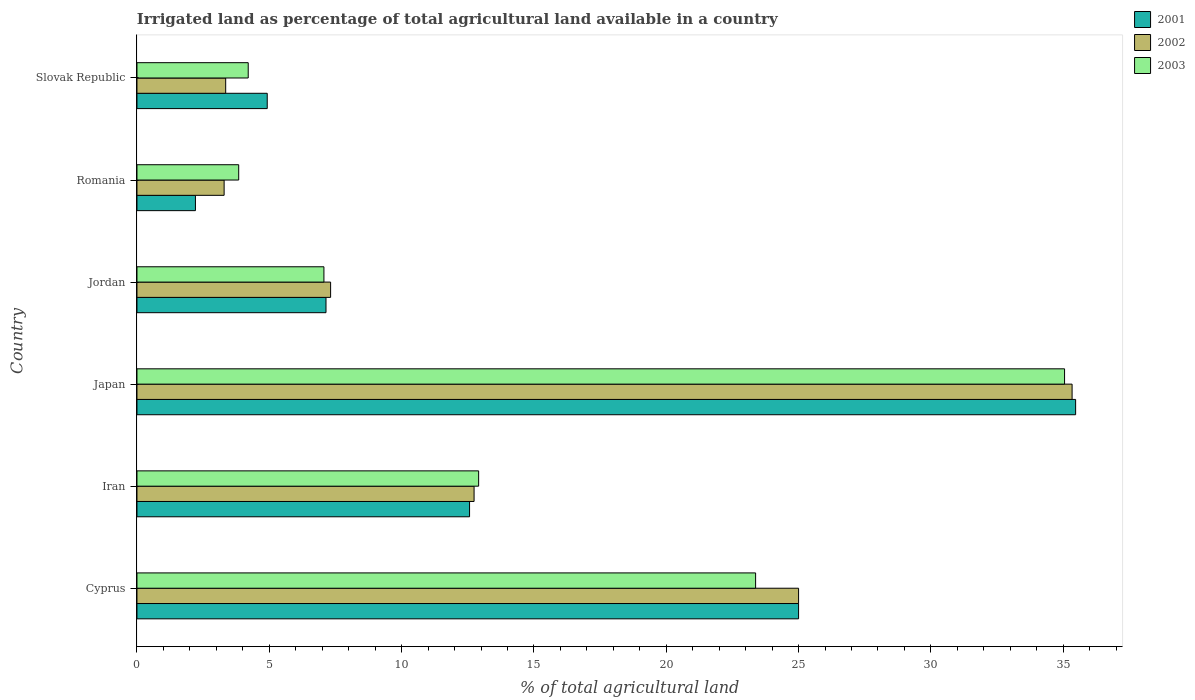How many different coloured bars are there?
Make the answer very short. 3. Are the number of bars per tick equal to the number of legend labels?
Keep it short and to the point. Yes. What is the label of the 6th group of bars from the top?
Offer a very short reply. Cyprus. In how many cases, is the number of bars for a given country not equal to the number of legend labels?
Offer a very short reply. 0. What is the percentage of irrigated land in 2003 in Japan?
Your answer should be compact. 35.05. Across all countries, what is the maximum percentage of irrigated land in 2003?
Offer a very short reply. 35.05. Across all countries, what is the minimum percentage of irrigated land in 2003?
Your response must be concise. 3.84. In which country was the percentage of irrigated land in 2002 minimum?
Provide a short and direct response. Romania. What is the total percentage of irrigated land in 2003 in the graph?
Offer a very short reply. 86.45. What is the difference between the percentage of irrigated land in 2002 in Iran and that in Jordan?
Make the answer very short. 5.42. What is the difference between the percentage of irrigated land in 2003 in Romania and the percentage of irrigated land in 2001 in Japan?
Offer a terse response. -31.62. What is the average percentage of irrigated land in 2002 per country?
Keep it short and to the point. 14.51. In how many countries, is the percentage of irrigated land in 2002 greater than 7 %?
Offer a very short reply. 4. What is the ratio of the percentage of irrigated land in 2001 in Romania to that in Slovak Republic?
Keep it short and to the point. 0.45. Is the difference between the percentage of irrigated land in 2001 in Jordan and Romania greater than the difference between the percentage of irrigated land in 2002 in Jordan and Romania?
Your answer should be very brief. Yes. What is the difference between the highest and the second highest percentage of irrigated land in 2001?
Keep it short and to the point. 10.47. What is the difference between the highest and the lowest percentage of irrigated land in 2003?
Keep it short and to the point. 31.21. In how many countries, is the percentage of irrigated land in 2001 greater than the average percentage of irrigated land in 2001 taken over all countries?
Offer a very short reply. 2. What does the 3rd bar from the top in Romania represents?
Your response must be concise. 2001. Is it the case that in every country, the sum of the percentage of irrigated land in 2002 and percentage of irrigated land in 2001 is greater than the percentage of irrigated land in 2003?
Your answer should be very brief. Yes. Are all the bars in the graph horizontal?
Make the answer very short. Yes. Does the graph contain any zero values?
Offer a very short reply. No. Where does the legend appear in the graph?
Provide a short and direct response. Top right. What is the title of the graph?
Your answer should be compact. Irrigated land as percentage of total agricultural land available in a country. Does "2000" appear as one of the legend labels in the graph?
Offer a terse response. No. What is the label or title of the X-axis?
Ensure brevity in your answer.  % of total agricultural land. What is the % of total agricultural land of 2002 in Cyprus?
Offer a very short reply. 25. What is the % of total agricultural land of 2003 in Cyprus?
Your answer should be very brief. 23.38. What is the % of total agricultural land of 2001 in Iran?
Keep it short and to the point. 12.57. What is the % of total agricultural land in 2002 in Iran?
Your answer should be very brief. 12.74. What is the % of total agricultural land in 2003 in Iran?
Provide a short and direct response. 12.91. What is the % of total agricultural land of 2001 in Japan?
Your answer should be very brief. 35.47. What is the % of total agricultural land in 2002 in Japan?
Provide a succinct answer. 35.33. What is the % of total agricultural land of 2003 in Japan?
Your answer should be compact. 35.05. What is the % of total agricultural land in 2001 in Jordan?
Provide a short and direct response. 7.14. What is the % of total agricultural land in 2002 in Jordan?
Provide a short and direct response. 7.32. What is the % of total agricultural land in 2003 in Jordan?
Offer a very short reply. 7.06. What is the % of total agricultural land of 2001 in Romania?
Provide a short and direct response. 2.21. What is the % of total agricultural land of 2002 in Romania?
Make the answer very short. 3.29. What is the % of total agricultural land of 2003 in Romania?
Ensure brevity in your answer.  3.84. What is the % of total agricultural land in 2001 in Slovak Republic?
Your answer should be compact. 4.92. What is the % of total agricultural land of 2002 in Slovak Republic?
Your response must be concise. 3.35. What is the % of total agricultural land of 2003 in Slovak Republic?
Ensure brevity in your answer.  4.2. Across all countries, what is the maximum % of total agricultural land of 2001?
Your answer should be very brief. 35.47. Across all countries, what is the maximum % of total agricultural land of 2002?
Ensure brevity in your answer.  35.33. Across all countries, what is the maximum % of total agricultural land in 2003?
Give a very brief answer. 35.05. Across all countries, what is the minimum % of total agricultural land of 2001?
Provide a short and direct response. 2.21. Across all countries, what is the minimum % of total agricultural land in 2002?
Ensure brevity in your answer.  3.29. Across all countries, what is the minimum % of total agricultural land of 2003?
Your answer should be very brief. 3.84. What is the total % of total agricultural land in 2001 in the graph?
Keep it short and to the point. 87.31. What is the total % of total agricultural land of 2002 in the graph?
Ensure brevity in your answer.  87.04. What is the total % of total agricultural land of 2003 in the graph?
Your answer should be compact. 86.45. What is the difference between the % of total agricultural land in 2001 in Cyprus and that in Iran?
Give a very brief answer. 12.43. What is the difference between the % of total agricultural land of 2002 in Cyprus and that in Iran?
Offer a very short reply. 12.26. What is the difference between the % of total agricultural land in 2003 in Cyprus and that in Iran?
Your answer should be very brief. 10.47. What is the difference between the % of total agricultural land in 2001 in Cyprus and that in Japan?
Provide a short and direct response. -10.47. What is the difference between the % of total agricultural land of 2002 in Cyprus and that in Japan?
Keep it short and to the point. -10.33. What is the difference between the % of total agricultural land of 2003 in Cyprus and that in Japan?
Ensure brevity in your answer.  -11.67. What is the difference between the % of total agricultural land of 2001 in Cyprus and that in Jordan?
Offer a very short reply. 17.86. What is the difference between the % of total agricultural land of 2002 in Cyprus and that in Jordan?
Make the answer very short. 17.68. What is the difference between the % of total agricultural land of 2003 in Cyprus and that in Jordan?
Give a very brief answer. 16.31. What is the difference between the % of total agricultural land in 2001 in Cyprus and that in Romania?
Give a very brief answer. 22.79. What is the difference between the % of total agricultural land in 2002 in Cyprus and that in Romania?
Provide a short and direct response. 21.71. What is the difference between the % of total agricultural land of 2003 in Cyprus and that in Romania?
Your answer should be compact. 19.53. What is the difference between the % of total agricultural land in 2001 in Cyprus and that in Slovak Republic?
Your answer should be very brief. 20.08. What is the difference between the % of total agricultural land of 2002 in Cyprus and that in Slovak Republic?
Keep it short and to the point. 21.65. What is the difference between the % of total agricultural land in 2003 in Cyprus and that in Slovak Republic?
Offer a terse response. 19.17. What is the difference between the % of total agricultural land in 2001 in Iran and that in Japan?
Make the answer very short. -22.9. What is the difference between the % of total agricultural land of 2002 in Iran and that in Japan?
Your response must be concise. -22.6. What is the difference between the % of total agricultural land of 2003 in Iran and that in Japan?
Ensure brevity in your answer.  -22.14. What is the difference between the % of total agricultural land in 2001 in Iran and that in Jordan?
Keep it short and to the point. 5.42. What is the difference between the % of total agricultural land of 2002 in Iran and that in Jordan?
Provide a succinct answer. 5.42. What is the difference between the % of total agricultural land of 2003 in Iran and that in Jordan?
Make the answer very short. 5.85. What is the difference between the % of total agricultural land of 2001 in Iran and that in Romania?
Keep it short and to the point. 10.36. What is the difference between the % of total agricultural land in 2002 in Iran and that in Romania?
Ensure brevity in your answer.  9.44. What is the difference between the % of total agricultural land in 2003 in Iran and that in Romania?
Give a very brief answer. 9.07. What is the difference between the % of total agricultural land in 2001 in Iran and that in Slovak Republic?
Keep it short and to the point. 7.65. What is the difference between the % of total agricultural land in 2002 in Iran and that in Slovak Republic?
Your answer should be compact. 9.39. What is the difference between the % of total agricultural land in 2003 in Iran and that in Slovak Republic?
Keep it short and to the point. 8.71. What is the difference between the % of total agricultural land of 2001 in Japan and that in Jordan?
Provide a short and direct response. 28.33. What is the difference between the % of total agricultural land of 2002 in Japan and that in Jordan?
Provide a short and direct response. 28.02. What is the difference between the % of total agricultural land of 2003 in Japan and that in Jordan?
Give a very brief answer. 27.99. What is the difference between the % of total agricultural land of 2001 in Japan and that in Romania?
Make the answer very short. 33.26. What is the difference between the % of total agricultural land of 2002 in Japan and that in Romania?
Your answer should be very brief. 32.04. What is the difference between the % of total agricultural land in 2003 in Japan and that in Romania?
Give a very brief answer. 31.21. What is the difference between the % of total agricultural land in 2001 in Japan and that in Slovak Republic?
Provide a short and direct response. 30.55. What is the difference between the % of total agricultural land in 2002 in Japan and that in Slovak Republic?
Provide a short and direct response. 31.98. What is the difference between the % of total agricultural land of 2003 in Japan and that in Slovak Republic?
Keep it short and to the point. 30.85. What is the difference between the % of total agricultural land in 2001 in Jordan and that in Romania?
Ensure brevity in your answer.  4.93. What is the difference between the % of total agricultural land in 2002 in Jordan and that in Romania?
Offer a very short reply. 4.02. What is the difference between the % of total agricultural land in 2003 in Jordan and that in Romania?
Make the answer very short. 3.22. What is the difference between the % of total agricultural land of 2001 in Jordan and that in Slovak Republic?
Offer a very short reply. 2.22. What is the difference between the % of total agricultural land in 2002 in Jordan and that in Slovak Republic?
Make the answer very short. 3.96. What is the difference between the % of total agricultural land of 2003 in Jordan and that in Slovak Republic?
Your response must be concise. 2.86. What is the difference between the % of total agricultural land of 2001 in Romania and that in Slovak Republic?
Provide a short and direct response. -2.71. What is the difference between the % of total agricultural land of 2002 in Romania and that in Slovak Republic?
Offer a terse response. -0.06. What is the difference between the % of total agricultural land of 2003 in Romania and that in Slovak Republic?
Make the answer very short. -0.36. What is the difference between the % of total agricultural land of 2001 in Cyprus and the % of total agricultural land of 2002 in Iran?
Your response must be concise. 12.26. What is the difference between the % of total agricultural land in 2001 in Cyprus and the % of total agricultural land in 2003 in Iran?
Provide a short and direct response. 12.09. What is the difference between the % of total agricultural land of 2002 in Cyprus and the % of total agricultural land of 2003 in Iran?
Provide a succinct answer. 12.09. What is the difference between the % of total agricultural land of 2001 in Cyprus and the % of total agricultural land of 2002 in Japan?
Offer a very short reply. -10.33. What is the difference between the % of total agricultural land in 2001 in Cyprus and the % of total agricultural land in 2003 in Japan?
Provide a succinct answer. -10.05. What is the difference between the % of total agricultural land of 2002 in Cyprus and the % of total agricultural land of 2003 in Japan?
Your answer should be compact. -10.05. What is the difference between the % of total agricultural land in 2001 in Cyprus and the % of total agricultural land in 2002 in Jordan?
Ensure brevity in your answer.  17.68. What is the difference between the % of total agricultural land in 2001 in Cyprus and the % of total agricultural land in 2003 in Jordan?
Ensure brevity in your answer.  17.94. What is the difference between the % of total agricultural land in 2002 in Cyprus and the % of total agricultural land in 2003 in Jordan?
Provide a succinct answer. 17.94. What is the difference between the % of total agricultural land in 2001 in Cyprus and the % of total agricultural land in 2002 in Romania?
Give a very brief answer. 21.71. What is the difference between the % of total agricultural land of 2001 in Cyprus and the % of total agricultural land of 2003 in Romania?
Give a very brief answer. 21.16. What is the difference between the % of total agricultural land of 2002 in Cyprus and the % of total agricultural land of 2003 in Romania?
Your answer should be compact. 21.16. What is the difference between the % of total agricultural land in 2001 in Cyprus and the % of total agricultural land in 2002 in Slovak Republic?
Offer a terse response. 21.65. What is the difference between the % of total agricultural land in 2001 in Cyprus and the % of total agricultural land in 2003 in Slovak Republic?
Your answer should be very brief. 20.8. What is the difference between the % of total agricultural land in 2002 in Cyprus and the % of total agricultural land in 2003 in Slovak Republic?
Your answer should be very brief. 20.8. What is the difference between the % of total agricultural land in 2001 in Iran and the % of total agricultural land in 2002 in Japan?
Your response must be concise. -22.77. What is the difference between the % of total agricultural land in 2001 in Iran and the % of total agricultural land in 2003 in Japan?
Provide a succinct answer. -22.48. What is the difference between the % of total agricultural land of 2002 in Iran and the % of total agricultural land of 2003 in Japan?
Your response must be concise. -22.31. What is the difference between the % of total agricultural land of 2001 in Iran and the % of total agricultural land of 2002 in Jordan?
Keep it short and to the point. 5.25. What is the difference between the % of total agricultural land in 2001 in Iran and the % of total agricultural land in 2003 in Jordan?
Give a very brief answer. 5.5. What is the difference between the % of total agricultural land in 2002 in Iran and the % of total agricultural land in 2003 in Jordan?
Provide a short and direct response. 5.67. What is the difference between the % of total agricultural land of 2001 in Iran and the % of total agricultural land of 2002 in Romania?
Make the answer very short. 9.27. What is the difference between the % of total agricultural land of 2001 in Iran and the % of total agricultural land of 2003 in Romania?
Keep it short and to the point. 8.72. What is the difference between the % of total agricultural land in 2002 in Iran and the % of total agricultural land in 2003 in Romania?
Offer a terse response. 8.89. What is the difference between the % of total agricultural land of 2001 in Iran and the % of total agricultural land of 2002 in Slovak Republic?
Your answer should be very brief. 9.21. What is the difference between the % of total agricultural land in 2001 in Iran and the % of total agricultural land in 2003 in Slovak Republic?
Give a very brief answer. 8.36. What is the difference between the % of total agricultural land in 2002 in Iran and the % of total agricultural land in 2003 in Slovak Republic?
Your response must be concise. 8.53. What is the difference between the % of total agricultural land in 2001 in Japan and the % of total agricultural land in 2002 in Jordan?
Your answer should be compact. 28.15. What is the difference between the % of total agricultural land in 2001 in Japan and the % of total agricultural land in 2003 in Jordan?
Your answer should be very brief. 28.4. What is the difference between the % of total agricultural land of 2002 in Japan and the % of total agricultural land of 2003 in Jordan?
Offer a very short reply. 28.27. What is the difference between the % of total agricultural land of 2001 in Japan and the % of total agricultural land of 2002 in Romania?
Offer a terse response. 32.18. What is the difference between the % of total agricultural land of 2001 in Japan and the % of total agricultural land of 2003 in Romania?
Your response must be concise. 31.62. What is the difference between the % of total agricultural land in 2002 in Japan and the % of total agricultural land in 2003 in Romania?
Offer a terse response. 31.49. What is the difference between the % of total agricultural land of 2001 in Japan and the % of total agricultural land of 2002 in Slovak Republic?
Provide a short and direct response. 32.12. What is the difference between the % of total agricultural land of 2001 in Japan and the % of total agricultural land of 2003 in Slovak Republic?
Offer a very short reply. 31.26. What is the difference between the % of total agricultural land in 2002 in Japan and the % of total agricultural land in 2003 in Slovak Republic?
Provide a short and direct response. 31.13. What is the difference between the % of total agricultural land in 2001 in Jordan and the % of total agricultural land in 2002 in Romania?
Offer a terse response. 3.85. What is the difference between the % of total agricultural land in 2001 in Jordan and the % of total agricultural land in 2003 in Romania?
Make the answer very short. 3.3. What is the difference between the % of total agricultural land in 2002 in Jordan and the % of total agricultural land in 2003 in Romania?
Give a very brief answer. 3.47. What is the difference between the % of total agricultural land in 2001 in Jordan and the % of total agricultural land in 2002 in Slovak Republic?
Keep it short and to the point. 3.79. What is the difference between the % of total agricultural land in 2001 in Jordan and the % of total agricultural land in 2003 in Slovak Republic?
Provide a succinct answer. 2.94. What is the difference between the % of total agricultural land of 2002 in Jordan and the % of total agricultural land of 2003 in Slovak Republic?
Offer a terse response. 3.11. What is the difference between the % of total agricultural land in 2001 in Romania and the % of total agricultural land in 2002 in Slovak Republic?
Offer a very short reply. -1.14. What is the difference between the % of total agricultural land in 2001 in Romania and the % of total agricultural land in 2003 in Slovak Republic?
Provide a succinct answer. -1.99. What is the difference between the % of total agricultural land of 2002 in Romania and the % of total agricultural land of 2003 in Slovak Republic?
Make the answer very short. -0.91. What is the average % of total agricultural land in 2001 per country?
Keep it short and to the point. 14.55. What is the average % of total agricultural land in 2002 per country?
Your response must be concise. 14.51. What is the average % of total agricultural land of 2003 per country?
Offer a very short reply. 14.41. What is the difference between the % of total agricultural land in 2001 and % of total agricultural land in 2002 in Cyprus?
Your response must be concise. 0. What is the difference between the % of total agricultural land in 2001 and % of total agricultural land in 2003 in Cyprus?
Offer a very short reply. 1.62. What is the difference between the % of total agricultural land in 2002 and % of total agricultural land in 2003 in Cyprus?
Offer a terse response. 1.62. What is the difference between the % of total agricultural land in 2001 and % of total agricultural land in 2002 in Iran?
Make the answer very short. -0.17. What is the difference between the % of total agricultural land of 2001 and % of total agricultural land of 2003 in Iran?
Offer a terse response. -0.34. What is the difference between the % of total agricultural land of 2002 and % of total agricultural land of 2003 in Iran?
Keep it short and to the point. -0.17. What is the difference between the % of total agricultural land in 2001 and % of total agricultural land in 2002 in Japan?
Your answer should be very brief. 0.13. What is the difference between the % of total agricultural land in 2001 and % of total agricultural land in 2003 in Japan?
Keep it short and to the point. 0.42. What is the difference between the % of total agricultural land of 2002 and % of total agricultural land of 2003 in Japan?
Your response must be concise. 0.28. What is the difference between the % of total agricultural land of 2001 and % of total agricultural land of 2002 in Jordan?
Offer a very short reply. -0.17. What is the difference between the % of total agricultural land of 2001 and % of total agricultural land of 2003 in Jordan?
Provide a succinct answer. 0.08. What is the difference between the % of total agricultural land in 2002 and % of total agricultural land in 2003 in Jordan?
Your response must be concise. 0.25. What is the difference between the % of total agricultural land in 2001 and % of total agricultural land in 2002 in Romania?
Make the answer very short. -1.08. What is the difference between the % of total agricultural land of 2001 and % of total agricultural land of 2003 in Romania?
Ensure brevity in your answer.  -1.63. What is the difference between the % of total agricultural land in 2002 and % of total agricultural land in 2003 in Romania?
Provide a short and direct response. -0.55. What is the difference between the % of total agricultural land of 2001 and % of total agricultural land of 2002 in Slovak Republic?
Give a very brief answer. 1.57. What is the difference between the % of total agricultural land of 2001 and % of total agricultural land of 2003 in Slovak Republic?
Provide a succinct answer. 0.72. What is the difference between the % of total agricultural land in 2002 and % of total agricultural land in 2003 in Slovak Republic?
Ensure brevity in your answer.  -0.85. What is the ratio of the % of total agricultural land of 2001 in Cyprus to that in Iran?
Offer a terse response. 1.99. What is the ratio of the % of total agricultural land of 2002 in Cyprus to that in Iran?
Your response must be concise. 1.96. What is the ratio of the % of total agricultural land in 2003 in Cyprus to that in Iran?
Keep it short and to the point. 1.81. What is the ratio of the % of total agricultural land in 2001 in Cyprus to that in Japan?
Make the answer very short. 0.7. What is the ratio of the % of total agricultural land of 2002 in Cyprus to that in Japan?
Make the answer very short. 0.71. What is the ratio of the % of total agricultural land of 2003 in Cyprus to that in Japan?
Keep it short and to the point. 0.67. What is the ratio of the % of total agricultural land in 2001 in Cyprus to that in Jordan?
Ensure brevity in your answer.  3.5. What is the ratio of the % of total agricultural land in 2002 in Cyprus to that in Jordan?
Provide a succinct answer. 3.42. What is the ratio of the % of total agricultural land in 2003 in Cyprus to that in Jordan?
Offer a terse response. 3.31. What is the ratio of the % of total agricultural land in 2001 in Cyprus to that in Romania?
Offer a terse response. 11.31. What is the ratio of the % of total agricultural land in 2002 in Cyprus to that in Romania?
Keep it short and to the point. 7.59. What is the ratio of the % of total agricultural land in 2003 in Cyprus to that in Romania?
Give a very brief answer. 6.08. What is the ratio of the % of total agricultural land in 2001 in Cyprus to that in Slovak Republic?
Your answer should be compact. 5.08. What is the ratio of the % of total agricultural land in 2002 in Cyprus to that in Slovak Republic?
Ensure brevity in your answer.  7.46. What is the ratio of the % of total agricultural land of 2003 in Cyprus to that in Slovak Republic?
Ensure brevity in your answer.  5.56. What is the ratio of the % of total agricultural land in 2001 in Iran to that in Japan?
Keep it short and to the point. 0.35. What is the ratio of the % of total agricultural land of 2002 in Iran to that in Japan?
Your response must be concise. 0.36. What is the ratio of the % of total agricultural land of 2003 in Iran to that in Japan?
Your answer should be very brief. 0.37. What is the ratio of the % of total agricultural land of 2001 in Iran to that in Jordan?
Your answer should be compact. 1.76. What is the ratio of the % of total agricultural land in 2002 in Iran to that in Jordan?
Your answer should be compact. 1.74. What is the ratio of the % of total agricultural land in 2003 in Iran to that in Jordan?
Offer a terse response. 1.83. What is the ratio of the % of total agricultural land in 2001 in Iran to that in Romania?
Your response must be concise. 5.69. What is the ratio of the % of total agricultural land of 2002 in Iran to that in Romania?
Give a very brief answer. 3.87. What is the ratio of the % of total agricultural land of 2003 in Iran to that in Romania?
Ensure brevity in your answer.  3.36. What is the ratio of the % of total agricultural land in 2001 in Iran to that in Slovak Republic?
Provide a succinct answer. 2.55. What is the ratio of the % of total agricultural land in 2002 in Iran to that in Slovak Republic?
Ensure brevity in your answer.  3.8. What is the ratio of the % of total agricultural land of 2003 in Iran to that in Slovak Republic?
Offer a terse response. 3.07. What is the ratio of the % of total agricultural land of 2001 in Japan to that in Jordan?
Your answer should be compact. 4.97. What is the ratio of the % of total agricultural land of 2002 in Japan to that in Jordan?
Provide a short and direct response. 4.83. What is the ratio of the % of total agricultural land of 2003 in Japan to that in Jordan?
Ensure brevity in your answer.  4.96. What is the ratio of the % of total agricultural land of 2001 in Japan to that in Romania?
Your answer should be compact. 16.05. What is the ratio of the % of total agricultural land in 2002 in Japan to that in Romania?
Make the answer very short. 10.73. What is the ratio of the % of total agricultural land of 2003 in Japan to that in Romania?
Provide a short and direct response. 9.12. What is the ratio of the % of total agricultural land in 2001 in Japan to that in Slovak Republic?
Make the answer very short. 7.21. What is the ratio of the % of total agricultural land in 2002 in Japan to that in Slovak Republic?
Ensure brevity in your answer.  10.54. What is the ratio of the % of total agricultural land of 2003 in Japan to that in Slovak Republic?
Provide a short and direct response. 8.34. What is the ratio of the % of total agricultural land of 2001 in Jordan to that in Romania?
Keep it short and to the point. 3.23. What is the ratio of the % of total agricultural land in 2002 in Jordan to that in Romania?
Give a very brief answer. 2.22. What is the ratio of the % of total agricultural land in 2003 in Jordan to that in Romania?
Make the answer very short. 1.84. What is the ratio of the % of total agricultural land in 2001 in Jordan to that in Slovak Republic?
Make the answer very short. 1.45. What is the ratio of the % of total agricultural land in 2002 in Jordan to that in Slovak Republic?
Provide a short and direct response. 2.18. What is the ratio of the % of total agricultural land in 2003 in Jordan to that in Slovak Republic?
Offer a terse response. 1.68. What is the ratio of the % of total agricultural land in 2001 in Romania to that in Slovak Republic?
Make the answer very short. 0.45. What is the ratio of the % of total agricultural land of 2002 in Romania to that in Slovak Republic?
Provide a succinct answer. 0.98. What is the ratio of the % of total agricultural land in 2003 in Romania to that in Slovak Republic?
Your answer should be compact. 0.91. What is the difference between the highest and the second highest % of total agricultural land of 2001?
Keep it short and to the point. 10.47. What is the difference between the highest and the second highest % of total agricultural land in 2002?
Offer a terse response. 10.33. What is the difference between the highest and the second highest % of total agricultural land in 2003?
Your answer should be compact. 11.67. What is the difference between the highest and the lowest % of total agricultural land in 2001?
Make the answer very short. 33.26. What is the difference between the highest and the lowest % of total agricultural land of 2002?
Provide a succinct answer. 32.04. What is the difference between the highest and the lowest % of total agricultural land in 2003?
Give a very brief answer. 31.21. 